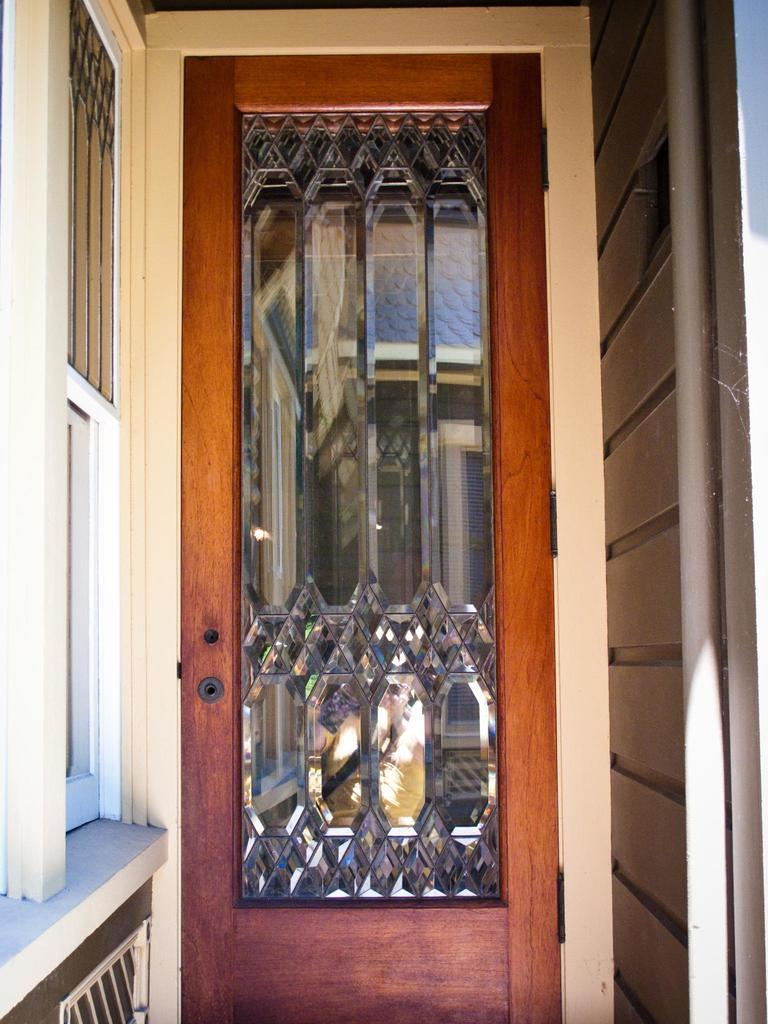What architectural feature can be seen in the image? There is a door, a window, and a wall in the image. What object is present in the image that is typically used for support? There is a pole in the image. What can be seen through the window in the image? The glass of the window shows a reflection of a person and a wall. How many chickens are visible in the image? There are no chickens present in the image. What type of cherries can be seen hanging from the wall in the image? There are no cherries present in the image. 